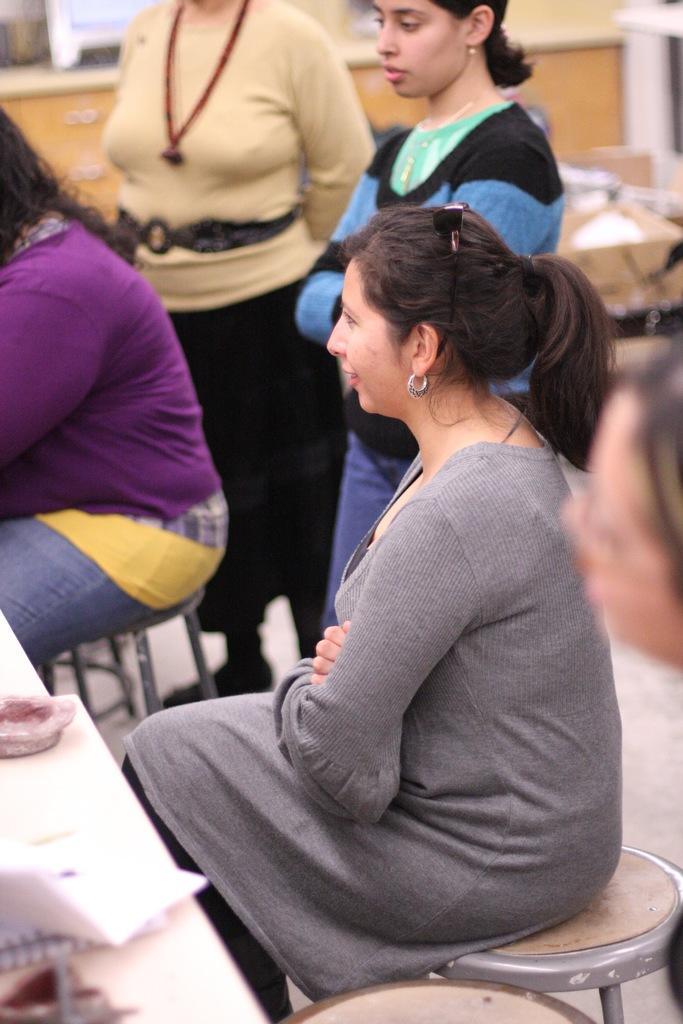Can you describe this image briefly? In this picture we can see a woman wearing a grey dress and sitting on the small table. Behind we can see three women are standing. In the background we can see a wooden partition board. 